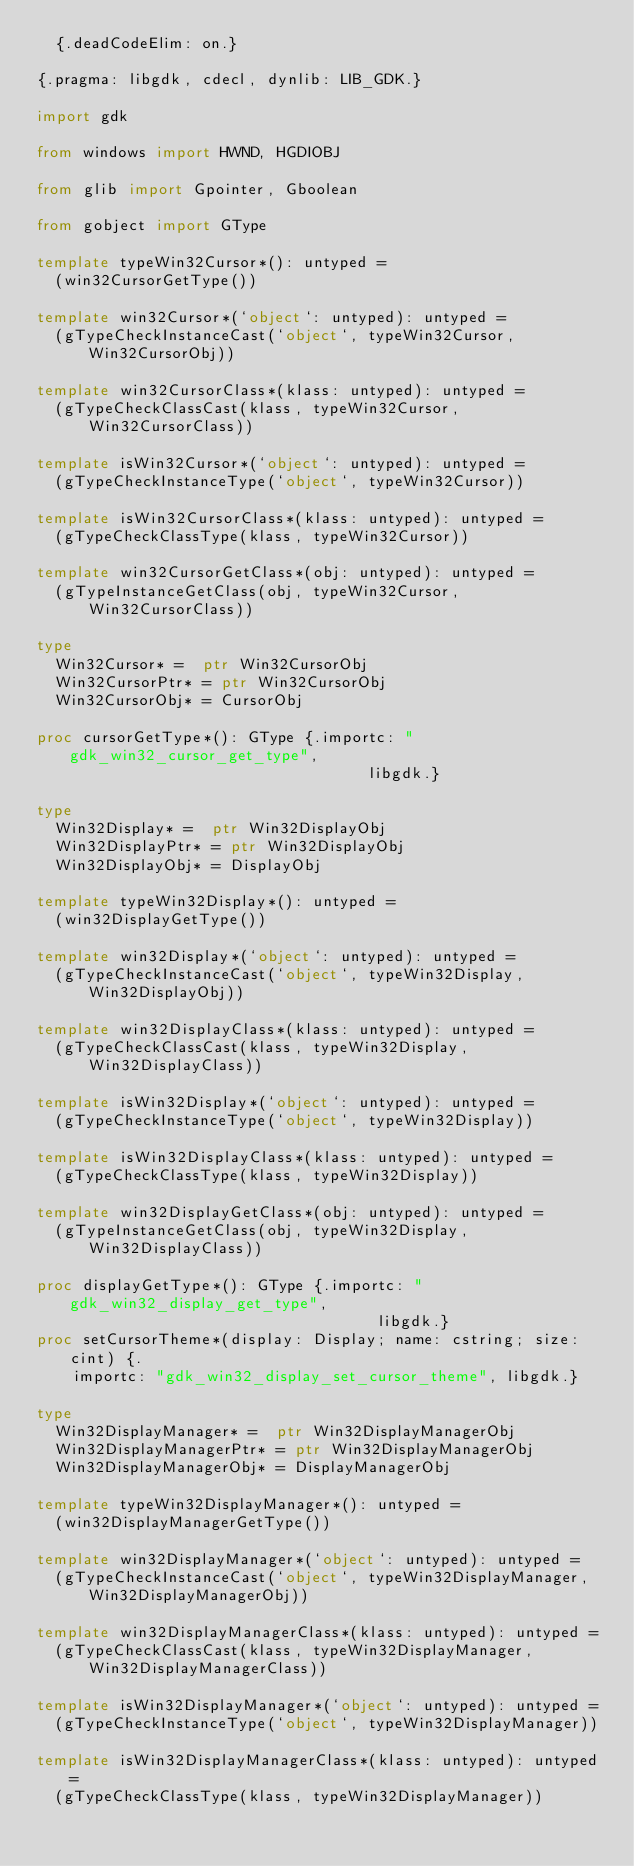Convert code to text. <code><loc_0><loc_0><loc_500><loc_500><_Nim_>  {.deadCodeElim: on.}

{.pragma: libgdk, cdecl, dynlib: LIB_GDK.}

import gdk

from windows import HWND, HGDIOBJ

from glib import Gpointer, Gboolean

from gobject import GType

template typeWin32Cursor*(): untyped =
  (win32CursorGetType())

template win32Cursor*(`object`: untyped): untyped =
  (gTypeCheckInstanceCast(`object`, typeWin32Cursor, Win32CursorObj))

template win32CursorClass*(klass: untyped): untyped =
  (gTypeCheckClassCast(klass, typeWin32Cursor, Win32CursorClass))

template isWin32Cursor*(`object`: untyped): untyped =
  (gTypeCheckInstanceType(`object`, typeWin32Cursor))

template isWin32CursorClass*(klass: untyped): untyped =
  (gTypeCheckClassType(klass, typeWin32Cursor))

template win32CursorGetClass*(obj: untyped): untyped =
  (gTypeInstanceGetClass(obj, typeWin32Cursor, Win32CursorClass))

type
  Win32Cursor* =  ptr Win32CursorObj
  Win32CursorPtr* = ptr Win32CursorObj
  Win32CursorObj* = CursorObj

proc cursorGetType*(): GType {.importc: "gdk_win32_cursor_get_type",
                                    libgdk.}

type
  Win32Display* =  ptr Win32DisplayObj
  Win32DisplayPtr* = ptr Win32DisplayObj
  Win32DisplayObj* = DisplayObj

template typeWin32Display*(): untyped =
  (win32DisplayGetType())

template win32Display*(`object`: untyped): untyped =
  (gTypeCheckInstanceCast(`object`, typeWin32Display, Win32DisplayObj))

template win32DisplayClass*(klass: untyped): untyped =
  (gTypeCheckClassCast(klass, typeWin32Display, Win32DisplayClass))

template isWin32Display*(`object`: untyped): untyped =
  (gTypeCheckInstanceType(`object`, typeWin32Display))

template isWin32DisplayClass*(klass: untyped): untyped =
  (gTypeCheckClassType(klass, typeWin32Display))

template win32DisplayGetClass*(obj: untyped): untyped =
  (gTypeInstanceGetClass(obj, typeWin32Display, Win32DisplayClass))

proc displayGetType*(): GType {.importc: "gdk_win32_display_get_type",
                                     libgdk.}
proc setCursorTheme*(display: Display; name: cstring; size: cint) {.
    importc: "gdk_win32_display_set_cursor_theme", libgdk.}

type
  Win32DisplayManager* =  ptr Win32DisplayManagerObj
  Win32DisplayManagerPtr* = ptr Win32DisplayManagerObj
  Win32DisplayManagerObj* = DisplayManagerObj

template typeWin32DisplayManager*(): untyped =
  (win32DisplayManagerGetType())

template win32DisplayManager*(`object`: untyped): untyped =
  (gTypeCheckInstanceCast(`object`, typeWin32DisplayManager, Win32DisplayManagerObj))

template win32DisplayManagerClass*(klass: untyped): untyped =
  (gTypeCheckClassCast(klass, typeWin32DisplayManager, Win32DisplayManagerClass))

template isWin32DisplayManager*(`object`: untyped): untyped =
  (gTypeCheckInstanceType(`object`, typeWin32DisplayManager))

template isWin32DisplayManagerClass*(klass: untyped): untyped =
  (gTypeCheckClassType(klass, typeWin32DisplayManager))
</code> 